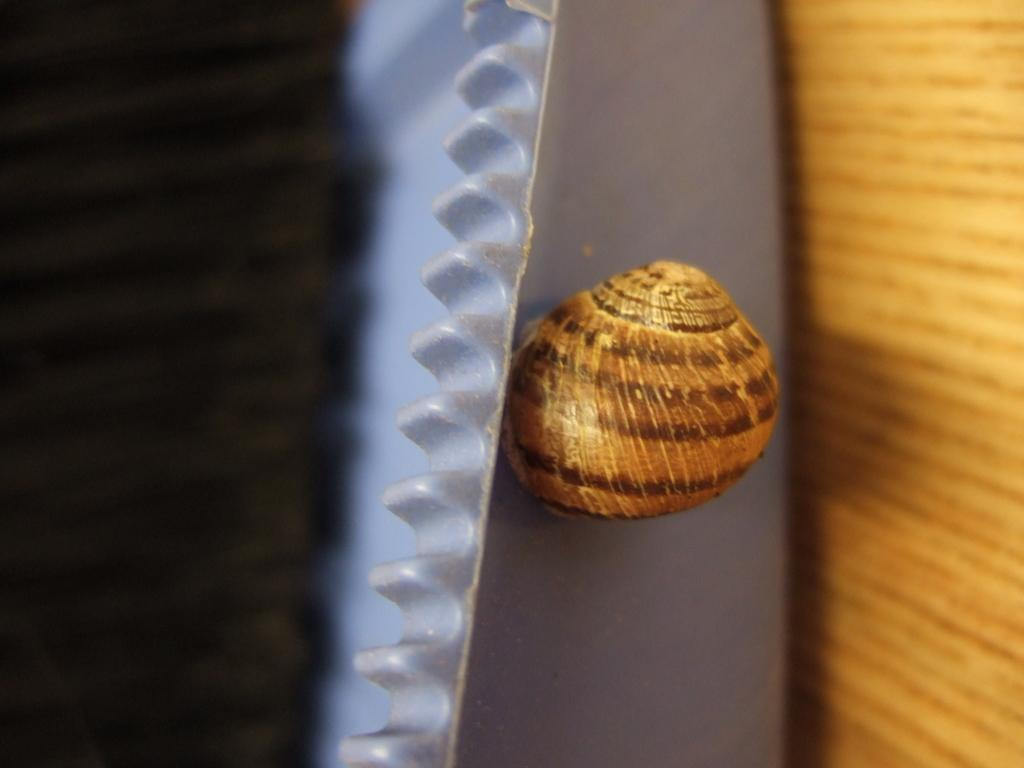What type of animal can be seen in the image? There is a snail in the image. Where is the snail located? The snail is on an object that resembles a tray. What can be seen on the right side of the image? There is a wooden object on the right side of the image. What type of window can be seen in the image? There is no window present in the image; it features a snail on a tray and a wooden object. Can you describe the flames in the image? There are no flames present in the image. 